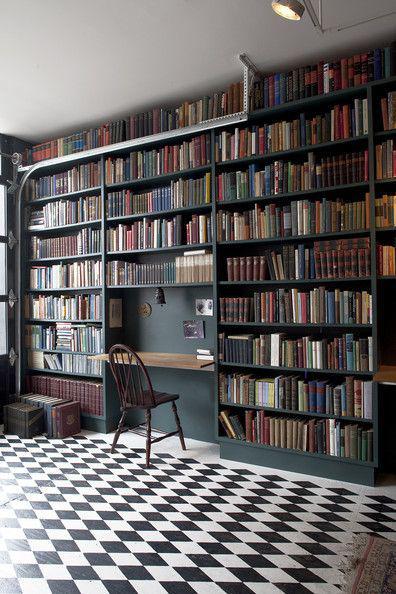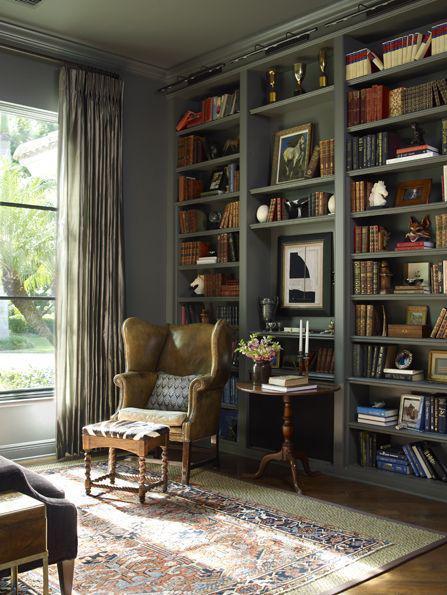The first image is the image on the left, the second image is the image on the right. Evaluate the accuracy of this statement regarding the images: "There is exactly one ladder.". Is it true? Answer yes or no. No. The first image is the image on the left, the second image is the image on the right. Analyze the images presented: Is the assertion "The right image shows a white ladder leaned against an upper shelf of a bookcase." valid? Answer yes or no. No. 